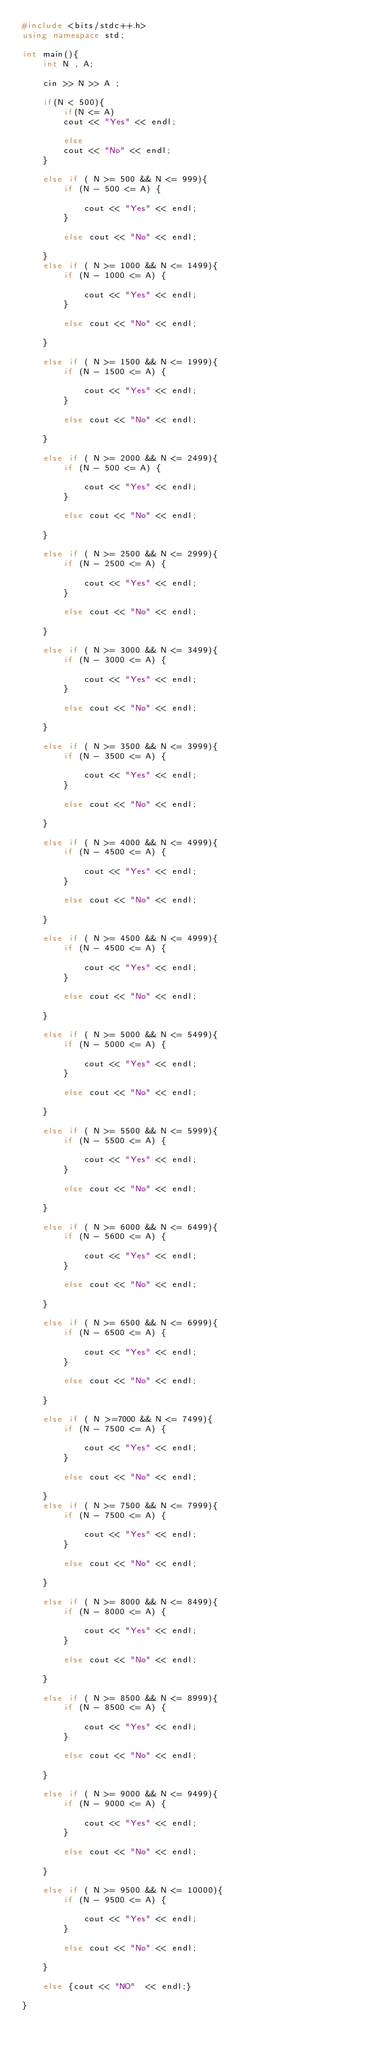Convert code to text. <code><loc_0><loc_0><loc_500><loc_500><_C++_>#include <bits/stdc++.h>
using namespace std;

int main(){
    int N , A;

    cin >> N >> A ;

    if(N < 500){
        if(N <= A)
        cout << "Yes" << endl;

        else
        cout << "No" << endl;
    }

    else if ( N >= 500 && N <= 999){
        if (N - 500 <= A) {

            cout << "Yes" << endl;
        }

        else cout << "No" << endl;

    }
    else if ( N >= 1000 && N <= 1499){
        if (N - 1000 <= A) {

            cout << "Yes" << endl;
        }

        else cout << "No" << endl;

    }

    else if ( N >= 1500 && N <= 1999){
        if (N - 1500 <= A) {

            cout << "Yes" << endl;
        }

        else cout << "No" << endl;
    
    }

    else if ( N >= 2000 && N <= 2499){
        if (N - 500 <= A) {

            cout << "Yes" << endl;
        }

        else cout << "No" << endl;
    
    }

    else if ( N >= 2500 && N <= 2999){
        if (N - 2500 <= A) {

            cout << "Yes" << endl;
        }

        else cout << "No" << endl;
    
    }

    else if ( N >= 3000 && N <= 3499){
        if (N - 3000 <= A) {

            cout << "Yes" << endl;
        }

        else cout << "No" << endl;

    }

    else if ( N >= 3500 && N <= 3999){
        if (N - 3500 <= A) {

            cout << "Yes" << endl;
        }

        else cout << "No" << endl;

    }

    else if ( N >= 4000 && N <= 4999){
        if (N - 4500 <= A) {

            cout << "Yes" << endl;
        }

        else cout << "No" << endl;  

    }
    
    else if ( N >= 4500 && N <= 4999){
        if (N - 4500 <= A) {

            cout << "Yes" << endl;
        }

        else cout << "No" << endl;

    }

    else if ( N >= 5000 && N <= 5499){
        if (N - 5000 <= A) {

            cout << "Yes" << endl;
        }

        else cout << "No" << endl;

    }

    else if ( N >= 5500 && N <= 5999){
        if (N - 5500 <= A) {

            cout << "Yes" << endl;
        }

        else cout << "No" << endl;

    }

    else if ( N >= 6000 && N <= 6499){
        if (N - 5600 <= A) {

            cout << "Yes" << endl;
        }

        else cout << "No" << endl;

    }

    else if ( N >= 6500 && N <= 6999){
        if (N - 6500 <= A) {

            cout << "Yes" << endl;
        }

        else cout << "No" << endl;

    }

    else if ( N >=7000 && N <= 7499){
        if (N - 7500 <= A) {

            cout << "Yes" << endl;
        }

        else cout << "No" << endl;

    }
    else if ( N >= 7500 && N <= 7999){
        if (N - 7500 <= A) {

            cout << "Yes" << endl;
        }

        else cout << "No" << endl;

    }

    else if ( N >= 8000 && N <= 8499){
        if (N - 8000 <= A) {

            cout << "Yes" << endl;
        }

        else cout << "No" << endl;

    }

    else if ( N >= 8500 && N <= 8999){
        if (N - 8500 <= A) {

            cout << "Yes" << endl;
        }

        else cout << "No" << endl;

    }

    else if ( N >= 9000 && N <= 9499){
        if (N - 9000 <= A) {

            cout << "Yes" << endl;
        }

        else cout << "No" << endl;

    }

    else if ( N >= 9500 && N <= 10000){
        if (N - 9500 <= A) {

            cout << "Yes" << endl;
        }

        else cout << "No" << endl;

    }

    else {cout << "NO"  << endl;}

}</code> 